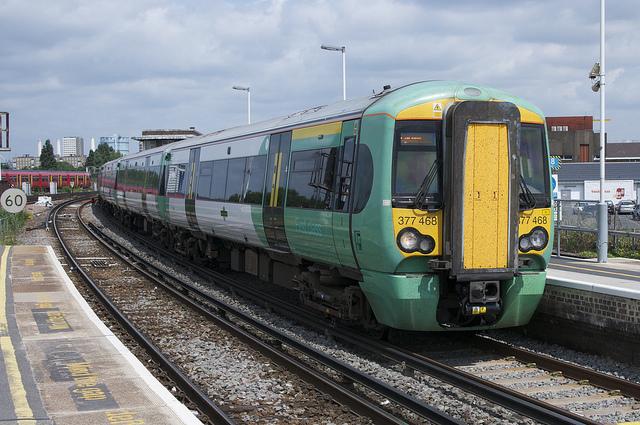How many tracks can you see here?
Quick response, please. 2. What numbers are on the train?
Concise answer only. 377468. Is this the front or back of the train?
Keep it brief. Front. What number is on the sign by the platform?
Be succinct. 60. How many railways are there?
Be succinct. 2. What side do people get on?
Short answer required. Right. 